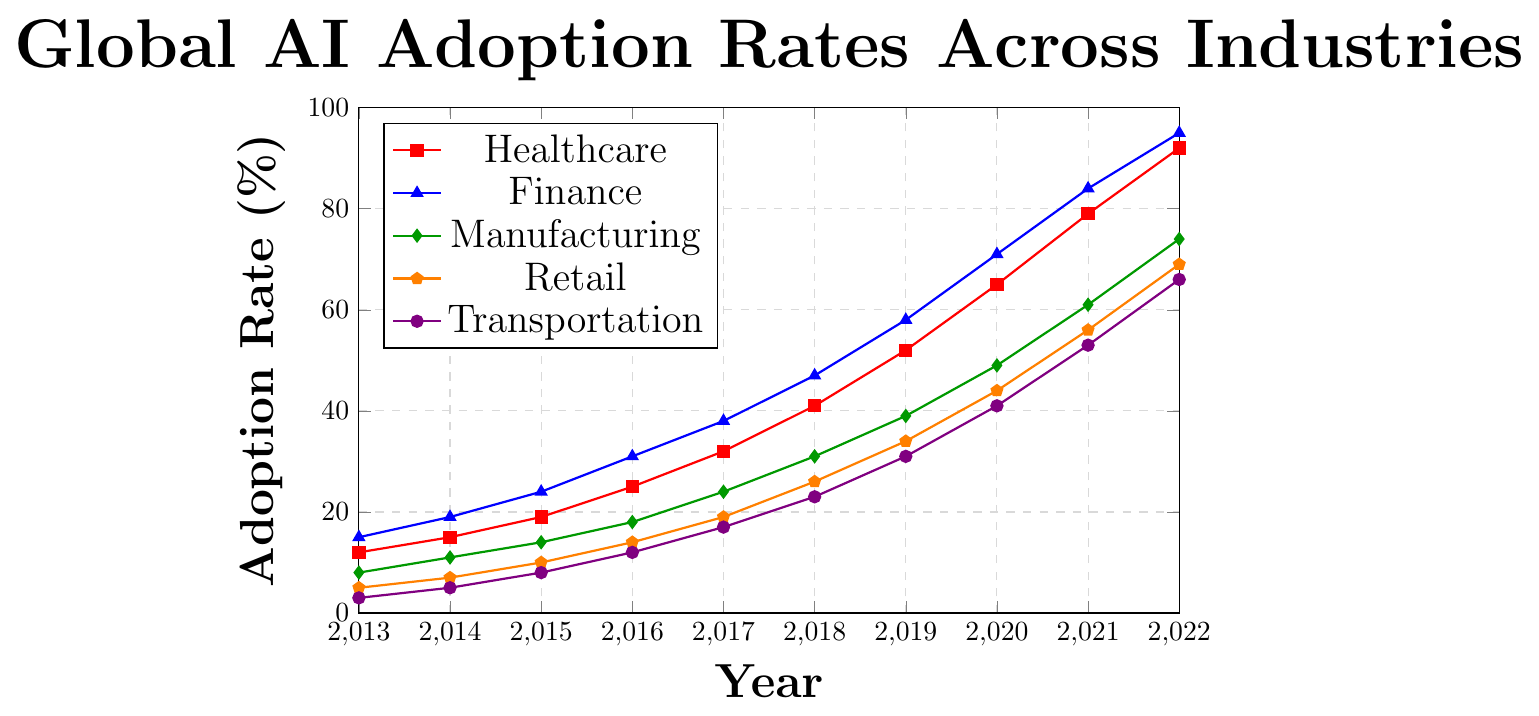Which industry had the highest AI adoption rate in 2022? By looking at the legend and the endpoints (2022) of the line chart, we see that the Finance industry, represented by the blue line, reaches 95%, which is the highest.
Answer: Finance What is the difference in AI adoption rates between Retail and Manufacturing in 2019? The Retail adoption rate in 2019 is 34%, and Manufacturing is 39%. The difference is calculated as 39% - 34% = 5%.
Answer: 5% How did the AI adoption rate in Healthcare change from 2013 to 2022? The Healthcare adoption rate in 2013 was 12%, and in 2022 it was 92%. The change is calculated as 92% - 12% = 80%.
Answer: 80% Which two industries had the closest adoption rates in 2014? In 2014, the adoption rates are: Healthcare (15%), Finance (19%), Manufacturing (11%), Retail (7%), and Transportation (5%). The closest rates are 7% (Retail) and 5% (Transportation), with a difference of 2%.
Answer: Retail and Transportation On average, how much did the AI adoption rate increase per year in the Transportation industry from 2013 to 2022? The adoption rate in Transportation increased from 3% in 2013 to 66% in 2022. The total increase over 9 years is calculated as 66% - 3% = 63%. Dividing this by 9 years, we get an average annual increase of 63% / 9 ≈ 7% per year.
Answer: 7% In which year did Manufacturing have a higher AI adoption rate than Retail for the first time? By comparing the data points, Manufacturing first surpassed Retail in 2015, with rates of 14% (Manufacturing) vs. 10% (Retail).
Answer: 2015 How many industries had an AI adoption rate of at least 50% in 2020? In 2020, the adoption rates are: Healthcare (65%), Finance (71%), Manufacturing (49%), Retail (44%), and Transportation (41%). Only Healthcare and Finance exceed 50% in 2020.
Answer: 2 What was the approximate average AI adoption rate across all industries in 2018? The adoption rates in 2018 are: Healthcare (41%), Finance (47%), Manufacturing (31%), Retail (26%), and Transportation (23%). The average is calculated as (41% + 47% + 31% + 26% + 23%) / 5 = 168% / 5 ≈ 33.6%.
Answer: 33.6% 